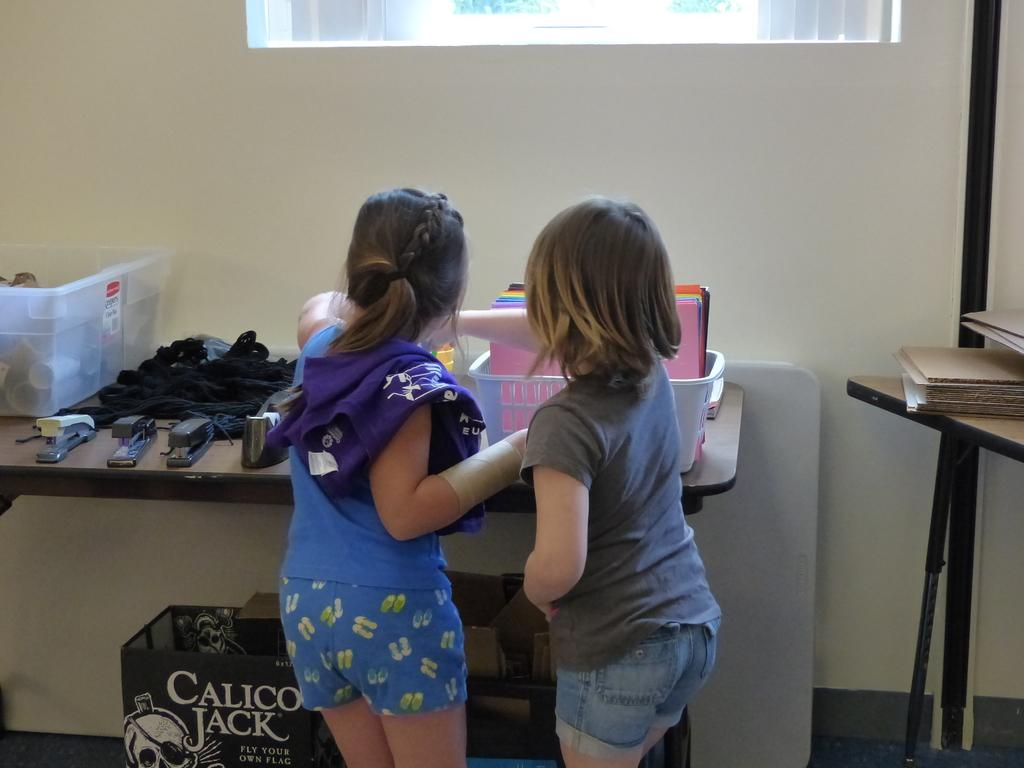<image>
Create a compact narrative representing the image presented. Nice to see two little girls busily sorting stationery items on a table, which is at odds with the Calico Jack box below them. 